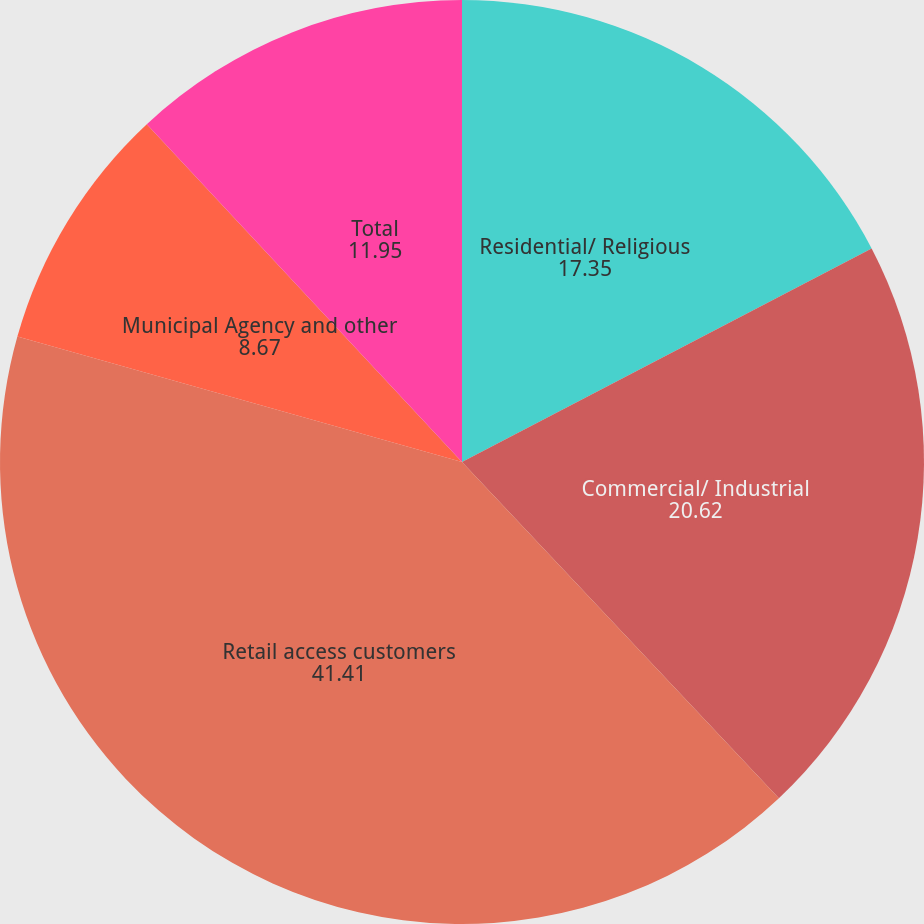Convert chart to OTSL. <chart><loc_0><loc_0><loc_500><loc_500><pie_chart><fcel>Residential/ Religious<fcel>Commercial/ Industrial<fcel>Retail access customers<fcel>Municipal Agency and other<fcel>Total<nl><fcel>17.35%<fcel>20.62%<fcel>41.41%<fcel>8.67%<fcel>11.95%<nl></chart> 